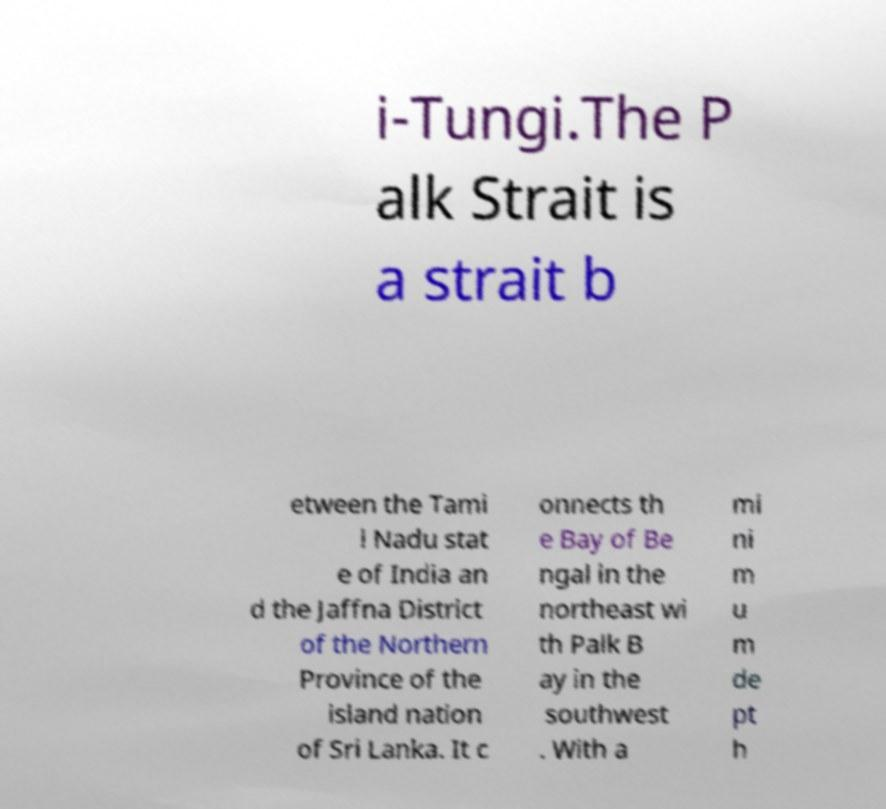Could you assist in decoding the text presented in this image and type it out clearly? i-Tungi.The P alk Strait is a strait b etween the Tami l Nadu stat e of India an d the Jaffna District of the Northern Province of the island nation of Sri Lanka. It c onnects th e Bay of Be ngal in the northeast wi th Palk B ay in the southwest . With a mi ni m u m de pt h 